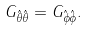<formula> <loc_0><loc_0><loc_500><loc_500>G _ { \hat { \theta } \hat { \theta } } = G _ { \hat { \phi } \hat { \phi } } .</formula> 